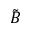Convert formula to latex. <formula><loc_0><loc_0><loc_500><loc_500>\tilde { B }</formula> 